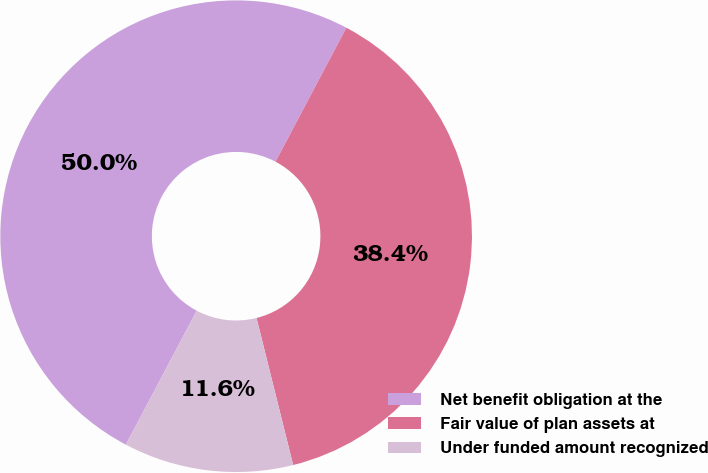<chart> <loc_0><loc_0><loc_500><loc_500><pie_chart><fcel>Net benefit obligation at the<fcel>Fair value of plan assets at<fcel>Under funded amount recognized<nl><fcel>50.0%<fcel>38.37%<fcel>11.63%<nl></chart> 